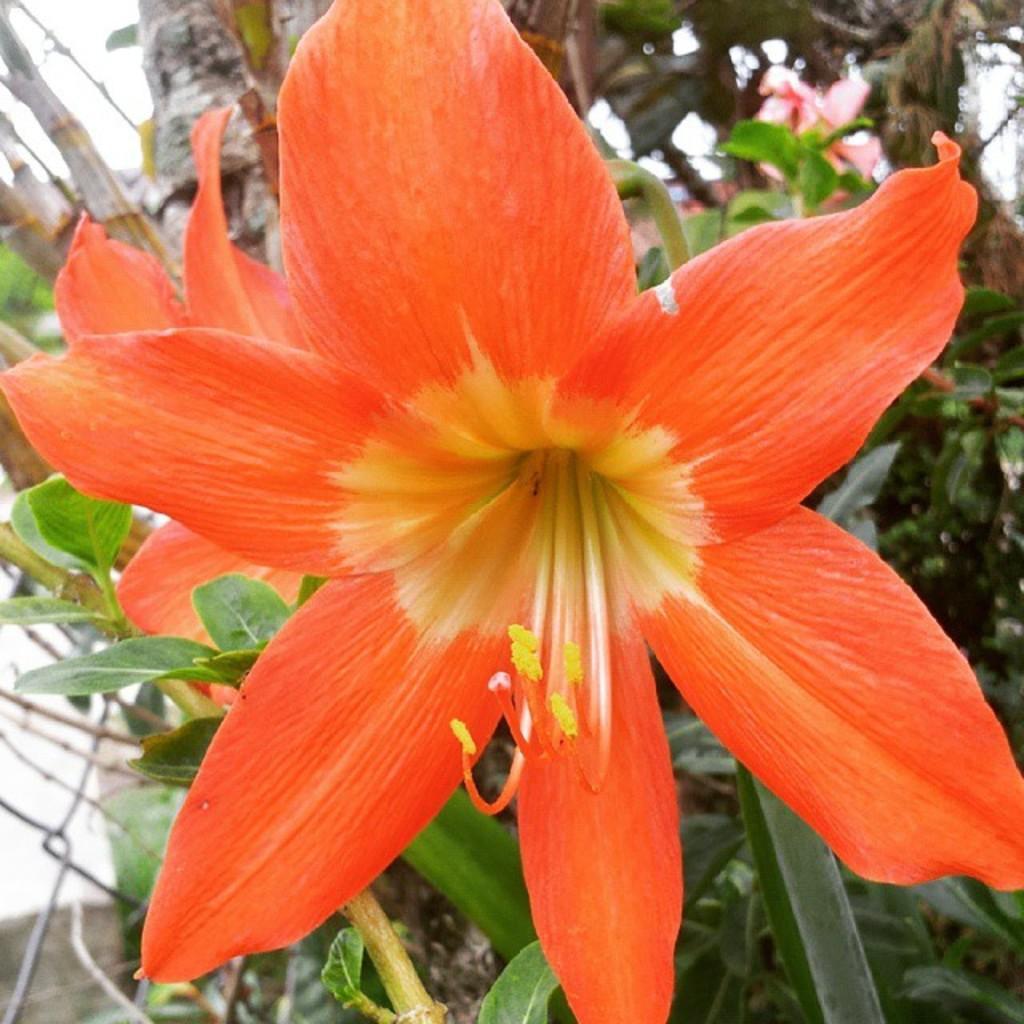In one or two sentences, can you explain what this image depicts? In this image, we can see few flowers with plants. Background there is a mesh, tree trunk we can see. 